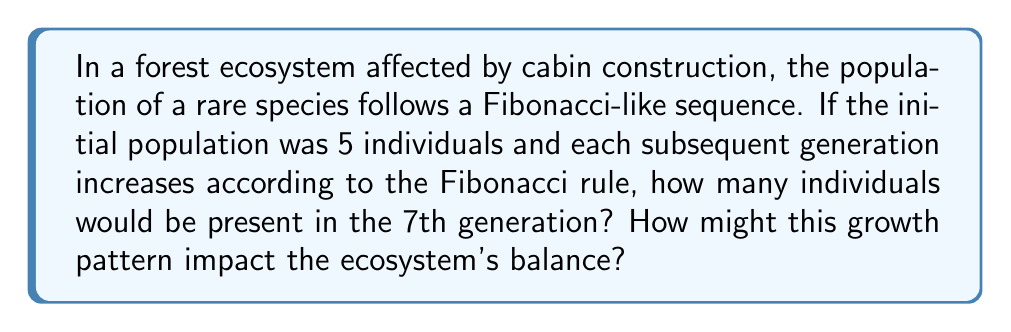Provide a solution to this math problem. To solve this problem, we need to follow these steps:

1. Recall the Fibonacci sequence rule: Each number is the sum of the two preceding ones.

2. Start with the given initial population: 5

3. Generate the sequence for 7 generations:
   Generation 1: 5
   Generation 2: 5 (assuming no change in the first generation)
   Generation 3: $5 + 5 = 10$
   Generation 4: $5 + 10 = 15$
   Generation 5: $10 + 15 = 25$
   Generation 6: $15 + 25 = 40$
   Generation 7: $25 + 40 = 65$

4. The population in the 7th generation is 65 individuals.

5. Ecological impact:
   This exponential growth pattern could lead to:
   a) Increased competition for resources
   b) Potential displacement of other species
   c) Alterations in food web dynamics
   d) Changes in nutrient cycling

6. Mitigation strategies:
   a) Implement habitat corridors to maintain genetic diversity
   b) Monitor and manage resource availability
   c) Consider controlled population management if necessary
   d) Conduct regular ecosystem assessments to track impacts

The Fibonacci-like growth can be represented mathematically as:

$$F_n = F_{n-1} + F_{n-2}$$

Where $F_n$ is the population in generation n, and $F_1 = F_2 = 5$ (our initial conditions).
Answer: 65 individuals 